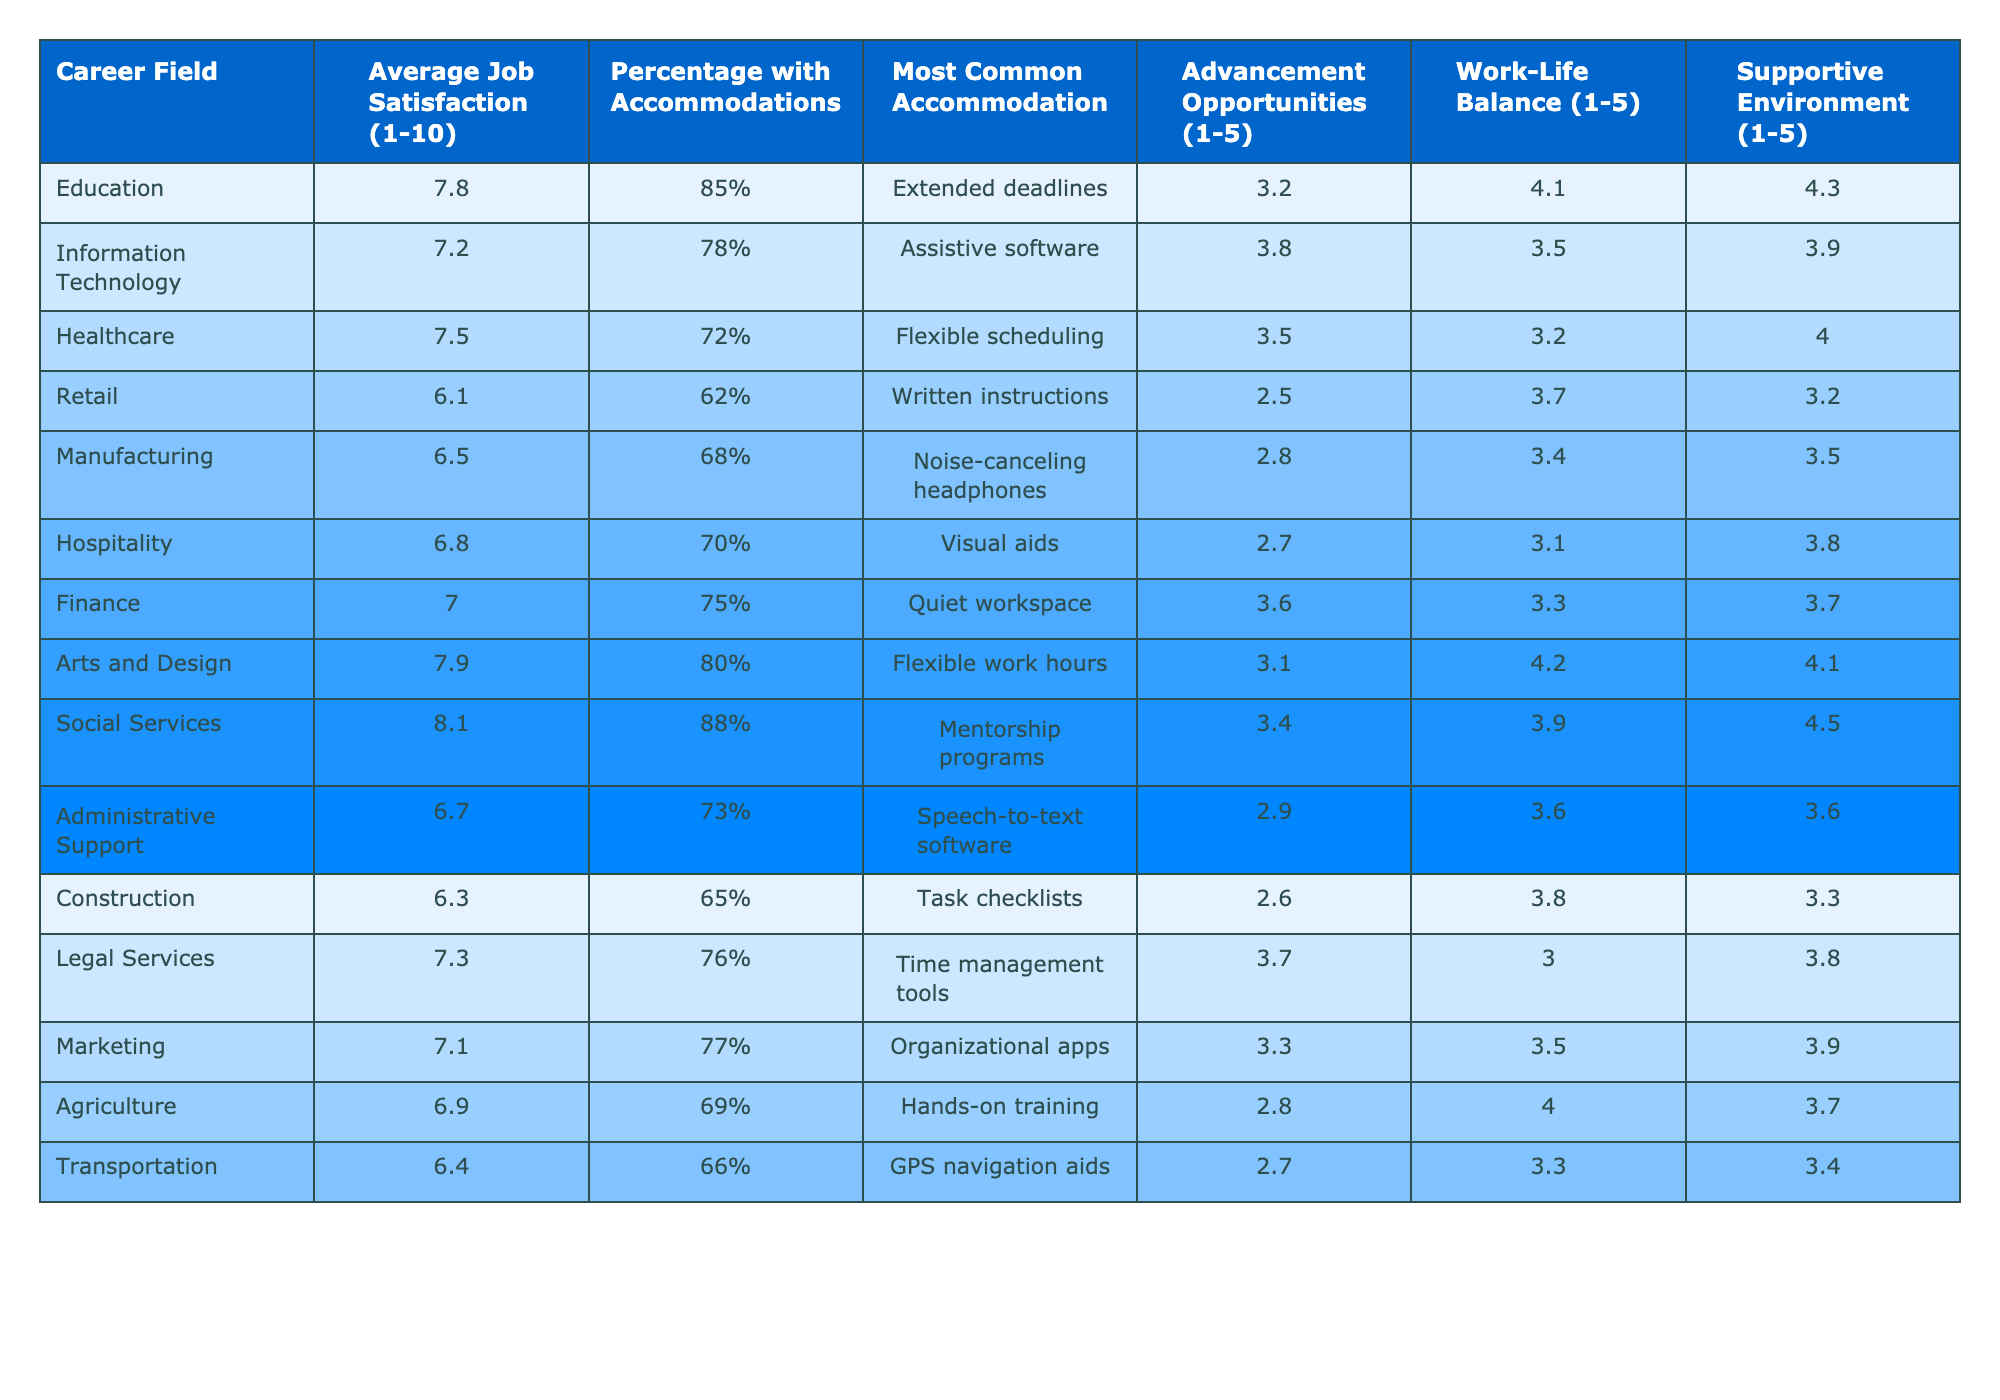What is the average job satisfaction level in the Education field? The table lists the average job satisfaction level for Education as 7.8.
Answer: 7.8 Which career field has the highest percentage of individuals receiving accommodations? The table shows that Social Services has the highest percentage at 88%.
Answer: 88% What is the most common accommodation in the Healthcare field? The table indicates that the most common accommodation in Healthcare is flexible scheduling.
Answer: Flexible scheduling What is the average advancement opportunity rating for the Transportation field? Referring to the table, the advancement opportunity rating for Transportation is 2.7.
Answer: 2.7 Is the average job satisfaction level in Arts and Design higher than that in Finance? The average job satisfaction level for Arts and Design is 7.9 and for Finance is 7.0, which confirms that Arts and Design is higher.
Answer: Yes What is the difference in average job satisfaction between Social Services and Retail? The average job satisfaction for Social Services is 8.1, while for Retail it is 6.1. The difference is 8.1 - 6.1 = 2.0.
Answer: 2.0 Which field has both the highest work-life balance and the highest supportive environment ratings? Looking at the table, Social Services has the highest work-life balance of 4.5 and also has the highest supportive environment rating of 4.5.
Answer: Social Services What is the median average job satisfaction score across all fields listed? The average job satisfaction scores, when arranged in order, are [6.1, 6.3, 6.4, 6.5, 6.7, 7.0, 7.1, 7.2, 7.5, 7.8, 7.9, 8.1]. There are 12 fields, so the median is the average of the 6th and 7th values: (7.0 + 7.1) / 2 = 7.05.
Answer: 7.05 If a person in the Manufacturing field was to switch to the Social Services field, what improvement in average job satisfaction would they experience? The average job satisfaction in Manufacturing is 6.5 and in Social Services it is 8.1. The improvement is 8.1 - 6.5 = 1.6.
Answer: 1.6 How many career fields have an average job satisfaction level above 7.5? The fields with job satisfaction levels above 7.5 are Education, Arts and Design, and Social Services, totaling 3 fields.
Answer: 3 